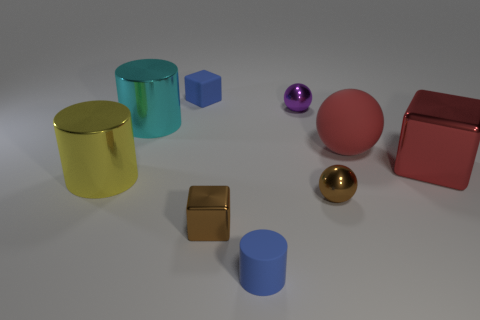What number of yellow objects have the same material as the big cyan cylinder? There is one yellow object that appears to have a similar reflective metallic material as the large cyan cylinder. 